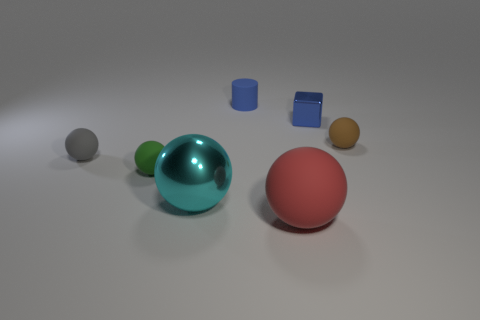Does the metal thing that is behind the tiny green matte sphere have the same color as the small object behind the tiny cube?
Make the answer very short. Yes. Are there more blue matte cylinders that are behind the cyan shiny sphere than gray rubber cylinders?
Your response must be concise. Yes. Is the brown object the same shape as the tiny blue rubber thing?
Your answer should be very brief. No. The red object has what size?
Make the answer very short. Large. Is the number of spheres right of the small gray sphere greater than the number of large metal balls right of the tiny shiny object?
Your answer should be compact. Yes. Are there any matte spheres in front of the green sphere?
Ensure brevity in your answer.  Yes. Is there a blue shiny object that has the same size as the blue rubber thing?
Give a very brief answer. Yes. There is a tiny cylinder that is made of the same material as the small gray thing; what color is it?
Provide a succinct answer. Blue. What is the tiny blue cube made of?
Make the answer very short. Metal. What is the shape of the cyan object?
Your answer should be very brief. Sphere. 